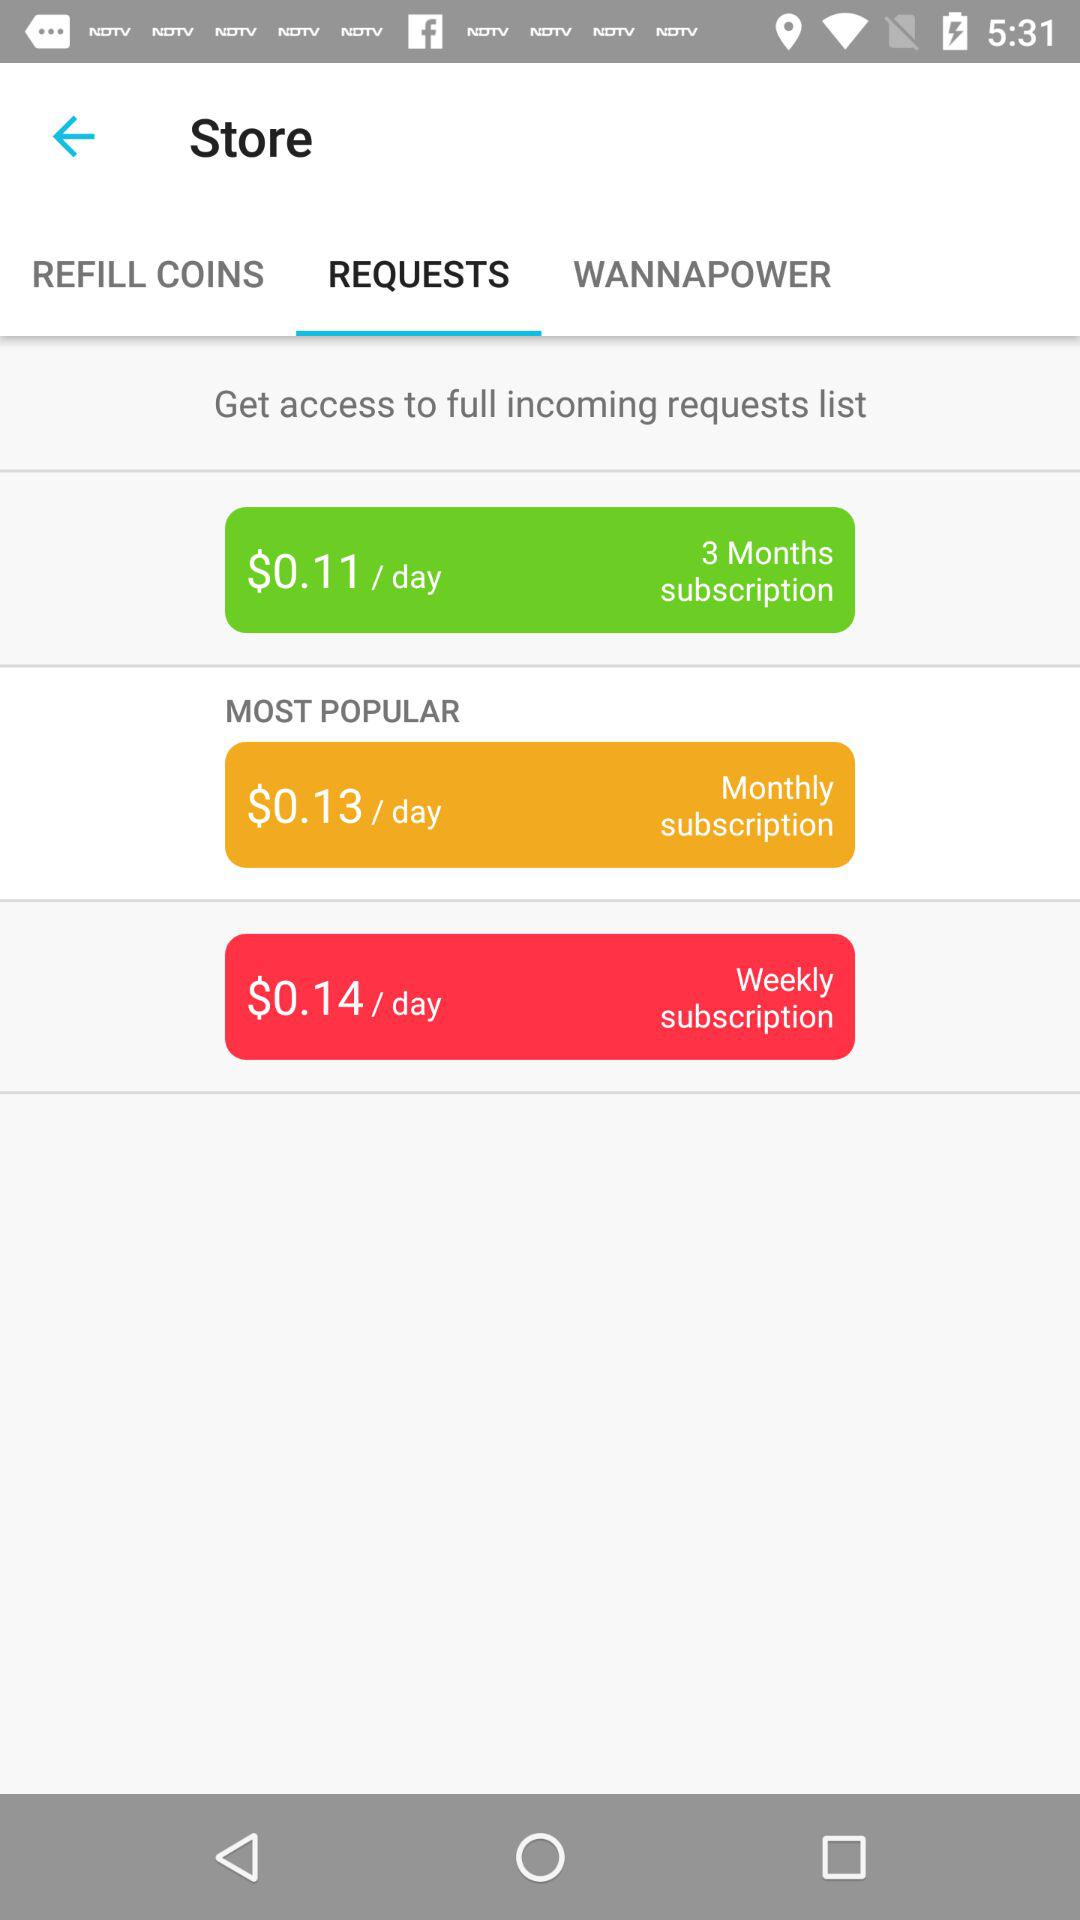What is the per-day cost for a monthly subscription? The per-day cost is $0.13. 